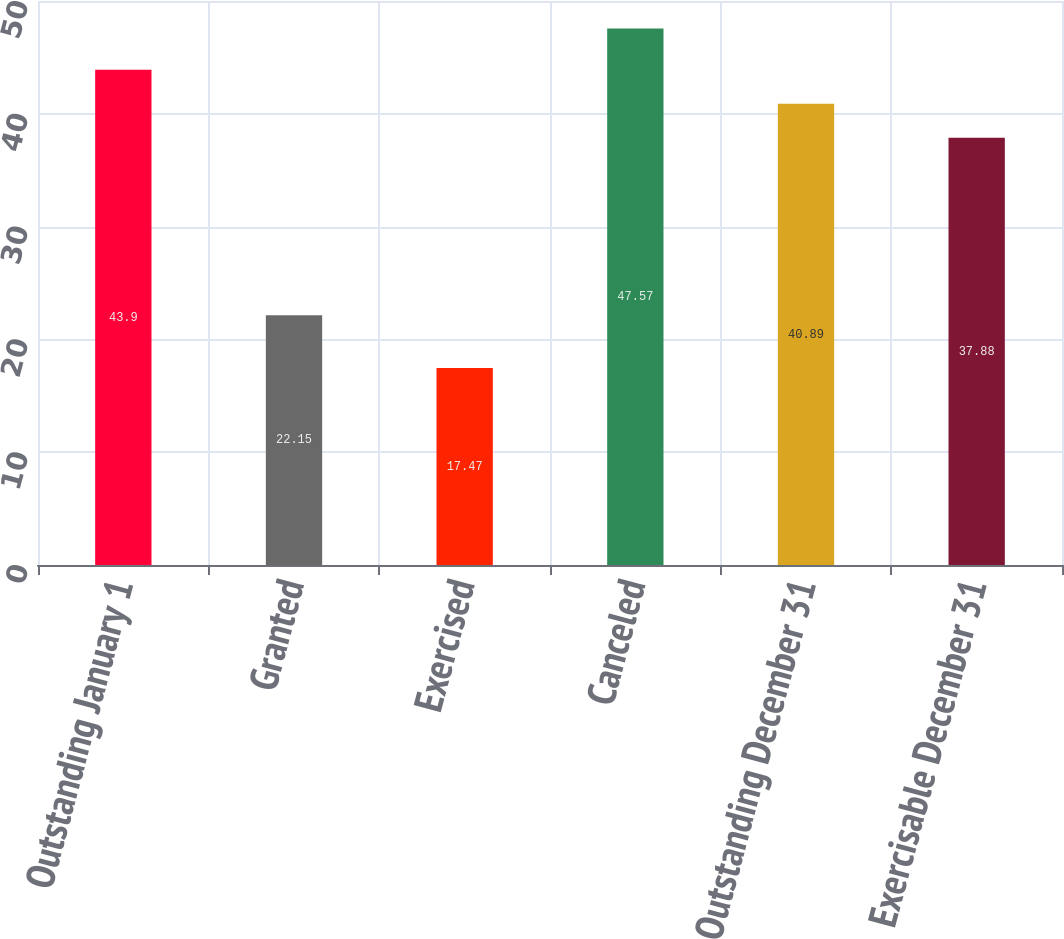Convert chart to OTSL. <chart><loc_0><loc_0><loc_500><loc_500><bar_chart><fcel>Outstanding January 1<fcel>Granted<fcel>Exercised<fcel>Canceled<fcel>Outstanding December 31<fcel>Exercisable December 31<nl><fcel>43.9<fcel>22.15<fcel>17.47<fcel>47.57<fcel>40.89<fcel>37.88<nl></chart> 